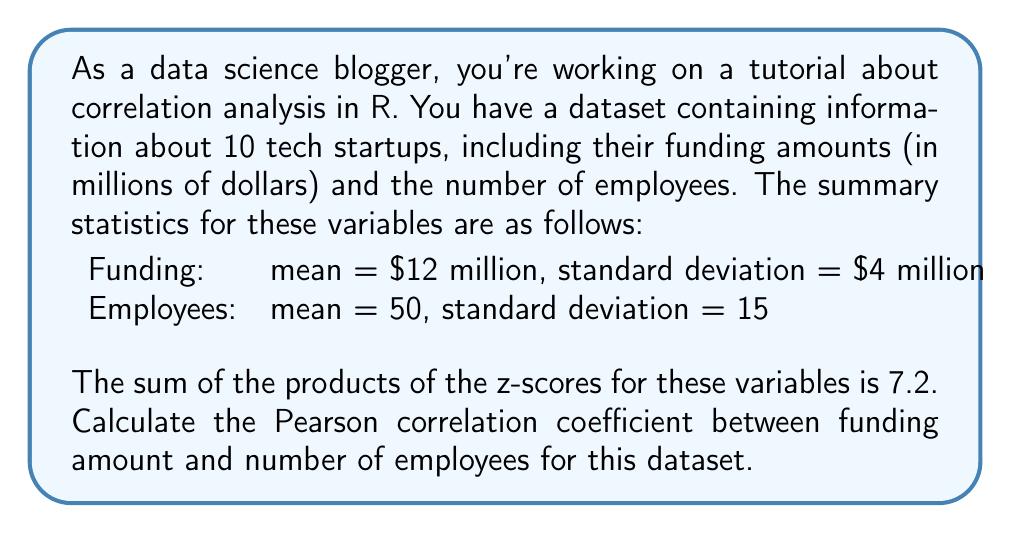Give your solution to this math problem. To find the Pearson correlation coefficient, we'll use the formula:

$$ r = \frac{\sum z_x z_y}{n} $$

Where:
$r$ is the correlation coefficient
$z_x$ and $z_y$ are the z-scores for variables x and y
$n$ is the number of data points

We're given that the sum of the products of the z-scores is 7.2, and we have 10 data points.

Simply plug these values into the formula:

$$ r = \frac{7.2}{10} = 0.72 $$

Note: In R, you could calculate this using the `cor()` function:

```r
cor(funding, employees)
```

This would give you the same result without manually calculating z-scores.
Answer: $r = 0.72$ 